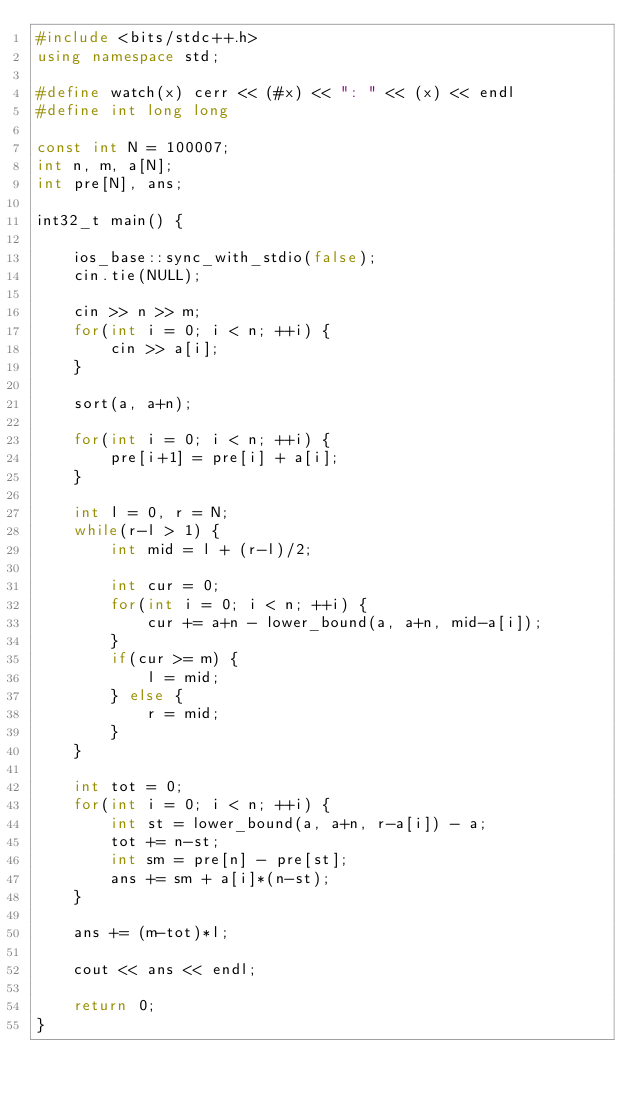<code> <loc_0><loc_0><loc_500><loc_500><_C++_>#include <bits/stdc++.h>
using namespace std;

#define watch(x) cerr << (#x) << ": " << (x) << endl
#define int long long

const int N = 100007;
int n, m, a[N];
int pre[N], ans;

int32_t main() {

    ios_base::sync_with_stdio(false);
    cin.tie(NULL);

    cin >> n >> m;
    for(int i = 0; i < n; ++i) {
        cin >> a[i];
    }

    sort(a, a+n);

    for(int i = 0; i < n; ++i) {
        pre[i+1] = pre[i] + a[i];
    }

    int l = 0, r = N;
    while(r-l > 1) {
        int mid = l + (r-l)/2;

        int cur = 0;
        for(int i = 0; i < n; ++i) {
            cur += a+n - lower_bound(a, a+n, mid-a[i]);
        }
        if(cur >= m) {
            l = mid;
        } else {
            r = mid;
        }
    }

    int tot = 0;
    for(int i = 0; i < n; ++i) {
        int st = lower_bound(a, a+n, r-a[i]) - a;
        tot += n-st;
        int sm = pre[n] - pre[st];
        ans += sm + a[i]*(n-st);
    }

    ans += (m-tot)*l;

    cout << ans << endl;
    
    return 0;
}
</code> 